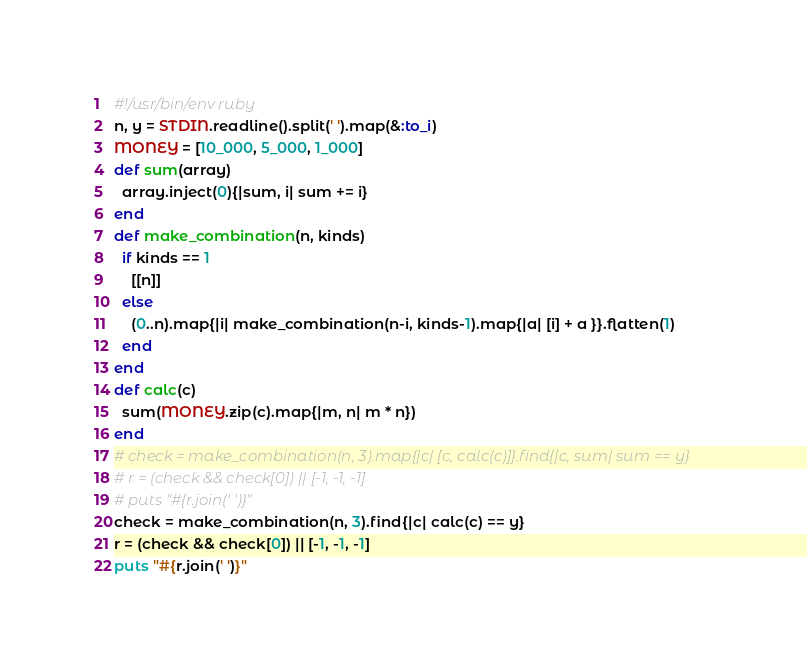<code> <loc_0><loc_0><loc_500><loc_500><_Ruby_>#!/usr/bin/env ruby
n, y = STDIN.readline().split(' ').map(&:to_i)
MONEY = [10_000, 5_000, 1_000]
def sum(array)
  array.inject(0){|sum, i| sum += i}
end
def make_combination(n, kinds)
  if kinds == 1
    [[n]]
  else
    (0..n).map{|i| make_combination(n-i, kinds-1).map{|a| [i] + a }}.flatten(1)
  end
end
def calc(c)
  sum(MONEY.zip(c).map{|m, n| m * n})
end
# check = make_combination(n, 3).map{|c| [c, calc(c)]}.find{|c, sum| sum == y}
# r = (check && check[0]) || [-1, -1, -1]
# puts "#{r.join(' ')}"
check = make_combination(n, 3).find{|c| calc(c) == y}
r = (check && check[0]) || [-1, -1, -1]
puts "#{r.join(' ')}"
</code> 